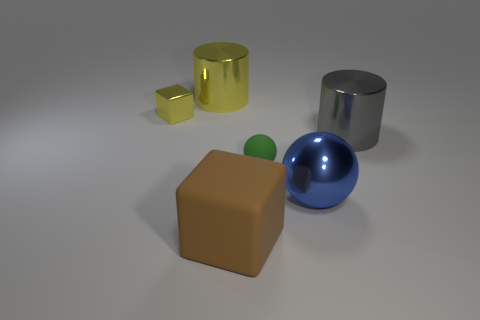Add 4 gray cylinders. How many objects exist? 10 Subtract all spheres. How many objects are left? 4 Add 1 tiny green matte spheres. How many tiny green matte spheres exist? 2 Subtract 1 blue balls. How many objects are left? 5 Subtract all small yellow blocks. Subtract all gray metal things. How many objects are left? 4 Add 1 blue balls. How many blue balls are left? 2 